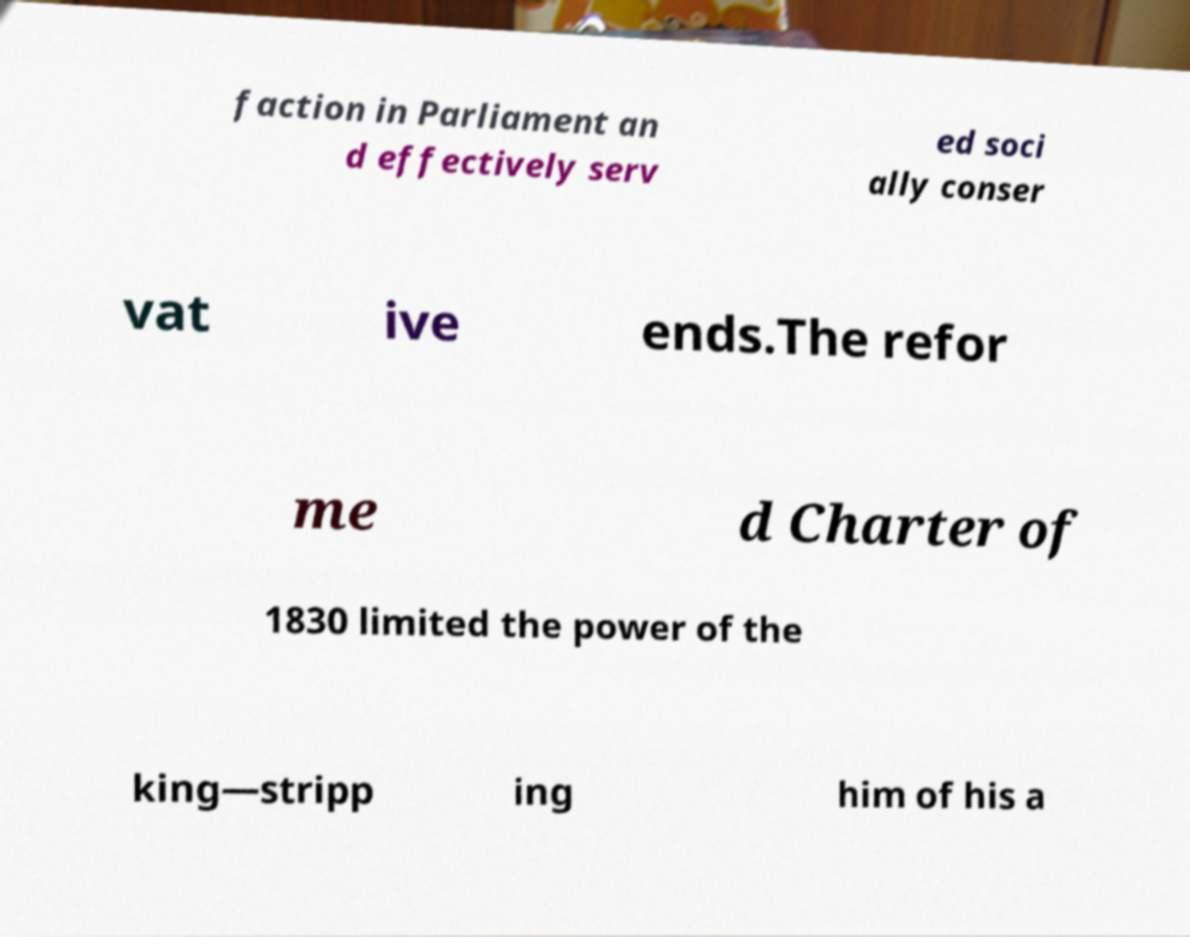Can you accurately transcribe the text from the provided image for me? faction in Parliament an d effectively serv ed soci ally conser vat ive ends.The refor me d Charter of 1830 limited the power of the king—stripp ing him of his a 